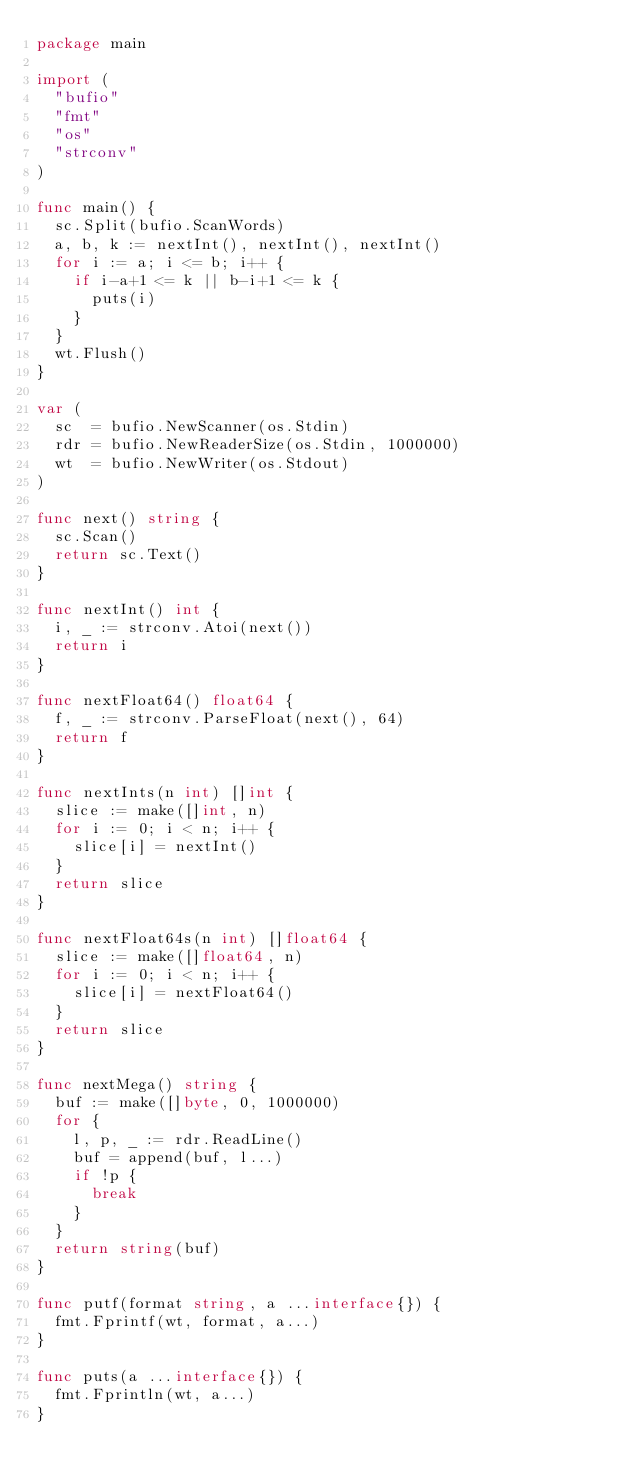<code> <loc_0><loc_0><loc_500><loc_500><_Go_>package main

import (
	"bufio"
	"fmt"
	"os"
	"strconv"
)

func main() {
	sc.Split(bufio.ScanWords)
	a, b, k := nextInt(), nextInt(), nextInt()
	for i := a; i <= b; i++ {
		if i-a+1 <= k || b-i+1 <= k {
			puts(i)
		}
	}
	wt.Flush()
}

var (
	sc  = bufio.NewScanner(os.Stdin)
	rdr = bufio.NewReaderSize(os.Stdin, 1000000)
	wt  = bufio.NewWriter(os.Stdout)
)

func next() string {
	sc.Scan()
	return sc.Text()
}

func nextInt() int {
	i, _ := strconv.Atoi(next())
	return i
}

func nextFloat64() float64 {
	f, _ := strconv.ParseFloat(next(), 64)
	return f
}

func nextInts(n int) []int {
	slice := make([]int, n)
	for i := 0; i < n; i++ {
		slice[i] = nextInt()
	}
	return slice
}

func nextFloat64s(n int) []float64 {
	slice := make([]float64, n)
	for i := 0; i < n; i++ {
		slice[i] = nextFloat64()
	}
	return slice
}

func nextMega() string {
	buf := make([]byte, 0, 1000000)
	for {
		l, p, _ := rdr.ReadLine()
		buf = append(buf, l...)
		if !p {
			break
		}
	}
	return string(buf)
}

func putf(format string, a ...interface{}) {
	fmt.Fprintf(wt, format, a...)
}

func puts(a ...interface{}) {
	fmt.Fprintln(wt, a...)
}
</code> 